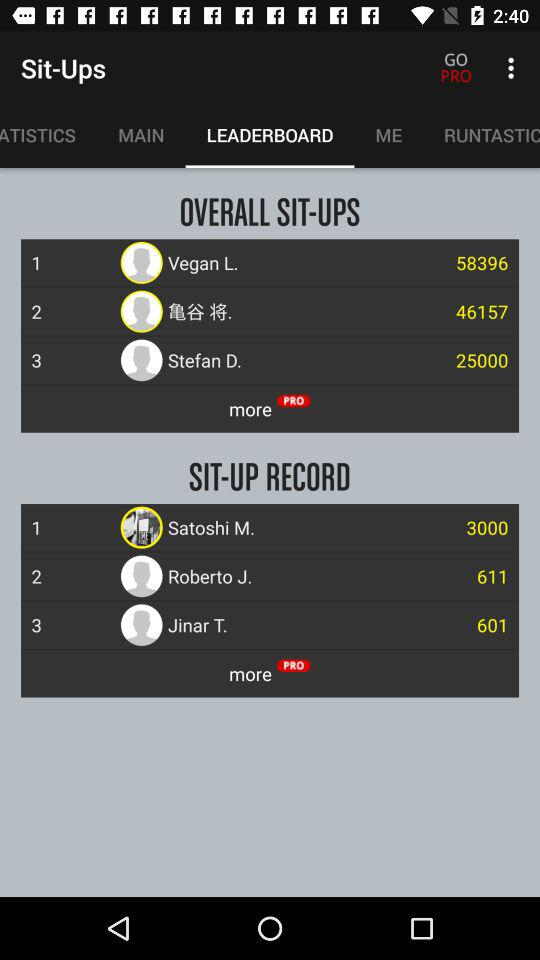What is the overall sit-up record of Stefan D.? The overall sit-up record is 25000. 